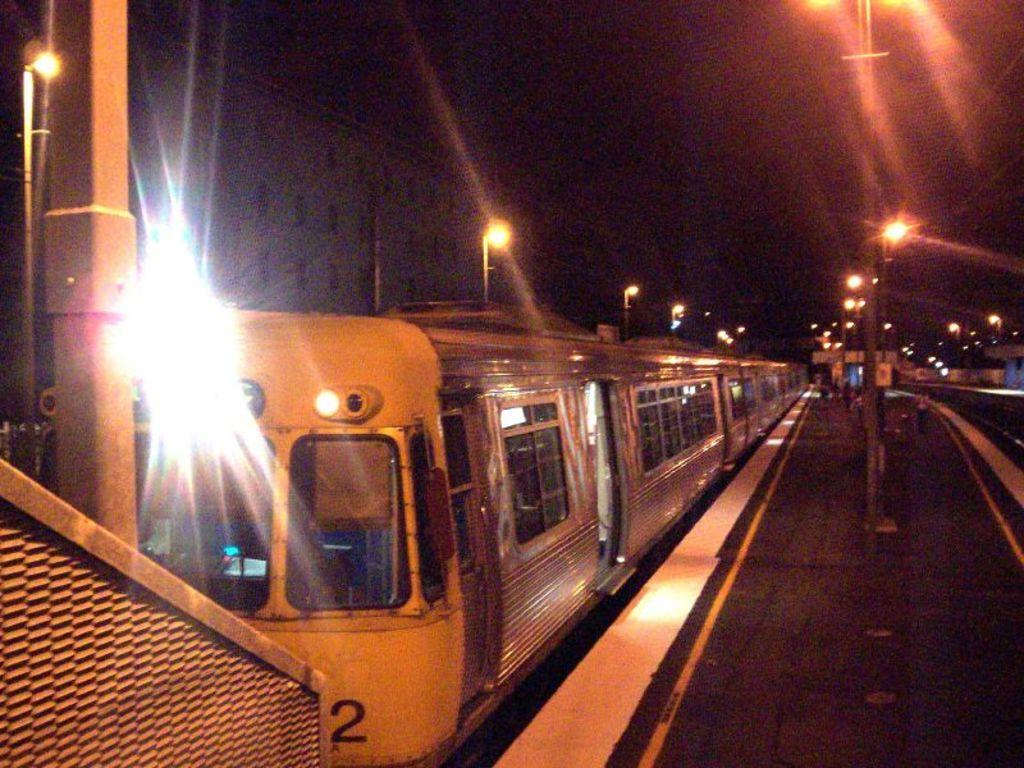<image>
Give a short and clear explanation of the subsequent image. the number two on the front of a train 